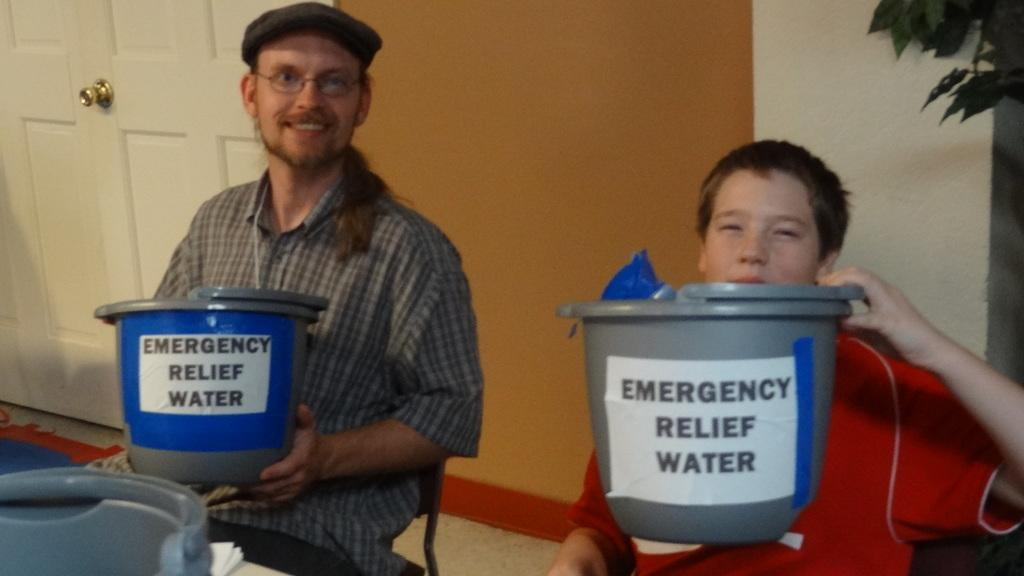<image>
Write a terse but informative summary of the picture. Two people are holding Emergency Relief Water buckets. 